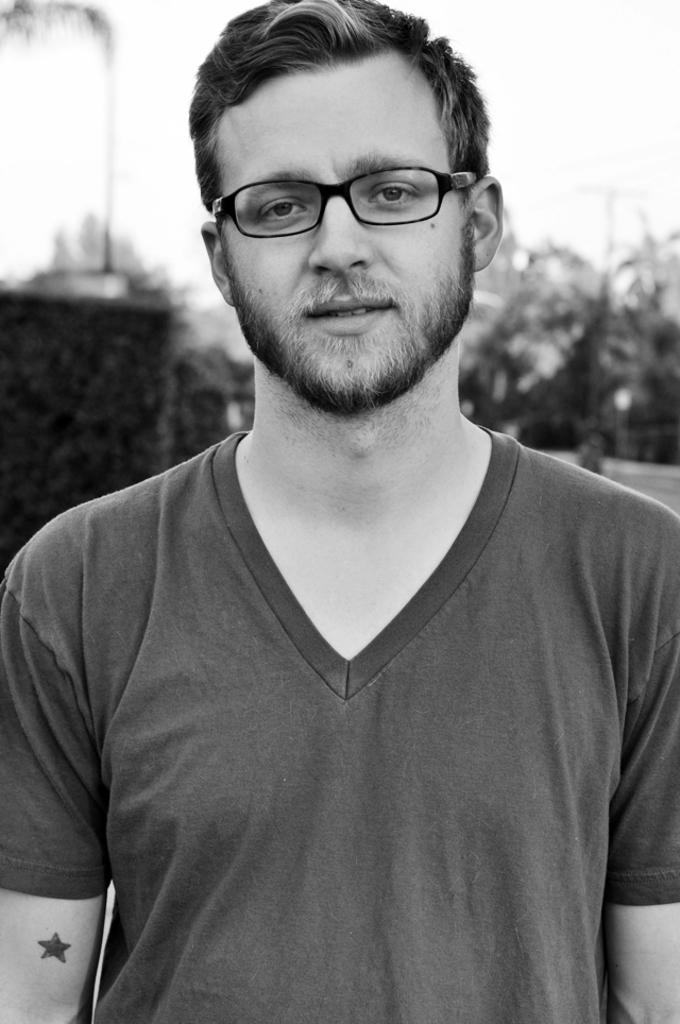What is the color scheme of the image? The image is black and white. Can you describe the person in the image? The person in the image is wearing spectacles. How would you describe the background of the image? The background of the image is blurred. How many frogs can be seen hopping in the image? There are no frogs present in the image. What shape is the boot that the person is wearing in the image? The person in the image is not wearing a boot, and there is no boot visible. 